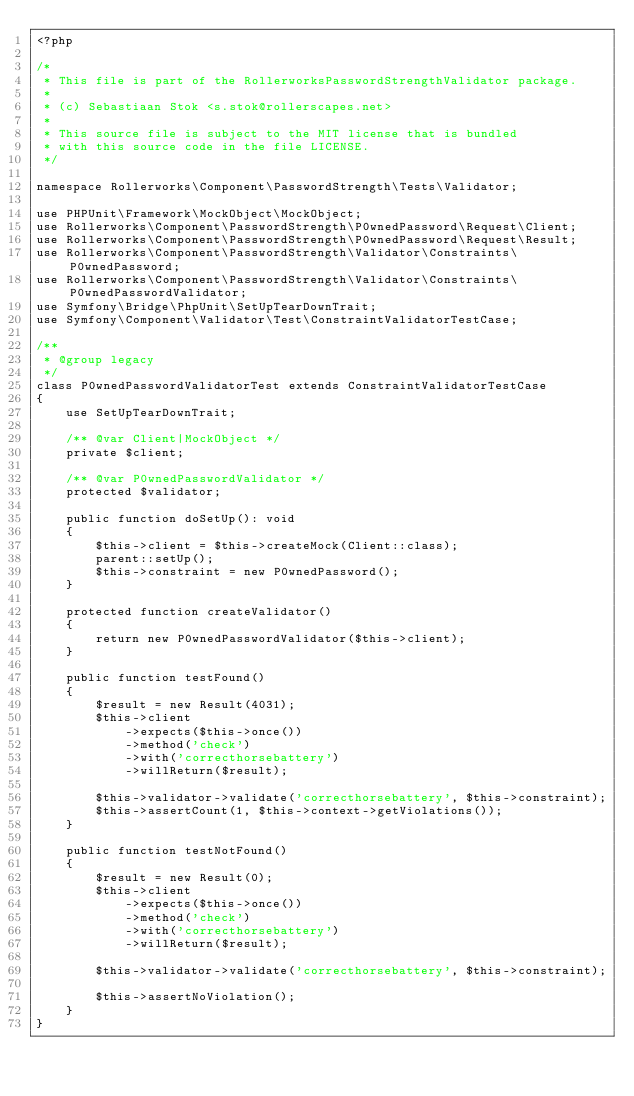Convert code to text. <code><loc_0><loc_0><loc_500><loc_500><_PHP_><?php

/*
 * This file is part of the RollerworksPasswordStrengthValidator package.
 *
 * (c) Sebastiaan Stok <s.stok@rollerscapes.net>
 *
 * This source file is subject to the MIT license that is bundled
 * with this source code in the file LICENSE.
 */

namespace Rollerworks\Component\PasswordStrength\Tests\Validator;

use PHPUnit\Framework\MockObject\MockObject;
use Rollerworks\Component\PasswordStrength\P0wnedPassword\Request\Client;
use Rollerworks\Component\PasswordStrength\P0wnedPassword\Request\Result;
use Rollerworks\Component\PasswordStrength\Validator\Constraints\P0wnedPassword;
use Rollerworks\Component\PasswordStrength\Validator\Constraints\P0wnedPasswordValidator;
use Symfony\Bridge\PhpUnit\SetUpTearDownTrait;
use Symfony\Component\Validator\Test\ConstraintValidatorTestCase;

/**
 * @group legacy
 */
class P0wnedPasswordValidatorTest extends ConstraintValidatorTestCase
{
    use SetUpTearDownTrait;

    /** @var Client|MockObject */
    private $client;

    /** @var P0wnedPasswordValidator */
    protected $validator;

    public function doSetUp(): void
    {
        $this->client = $this->createMock(Client::class);
        parent::setUp();
        $this->constraint = new P0wnedPassword();
    }

    protected function createValidator()
    {
        return new P0wnedPasswordValidator($this->client);
    }

    public function testFound()
    {
        $result = new Result(4031);
        $this->client
            ->expects($this->once())
            ->method('check')
            ->with('correcthorsebattery')
            ->willReturn($result);

        $this->validator->validate('correcthorsebattery', $this->constraint);
        $this->assertCount(1, $this->context->getViolations());
    }

    public function testNotFound()
    {
        $result = new Result(0);
        $this->client
            ->expects($this->once())
            ->method('check')
            ->with('correcthorsebattery')
            ->willReturn($result);

        $this->validator->validate('correcthorsebattery', $this->constraint);

        $this->assertNoViolation();
    }
}
</code> 